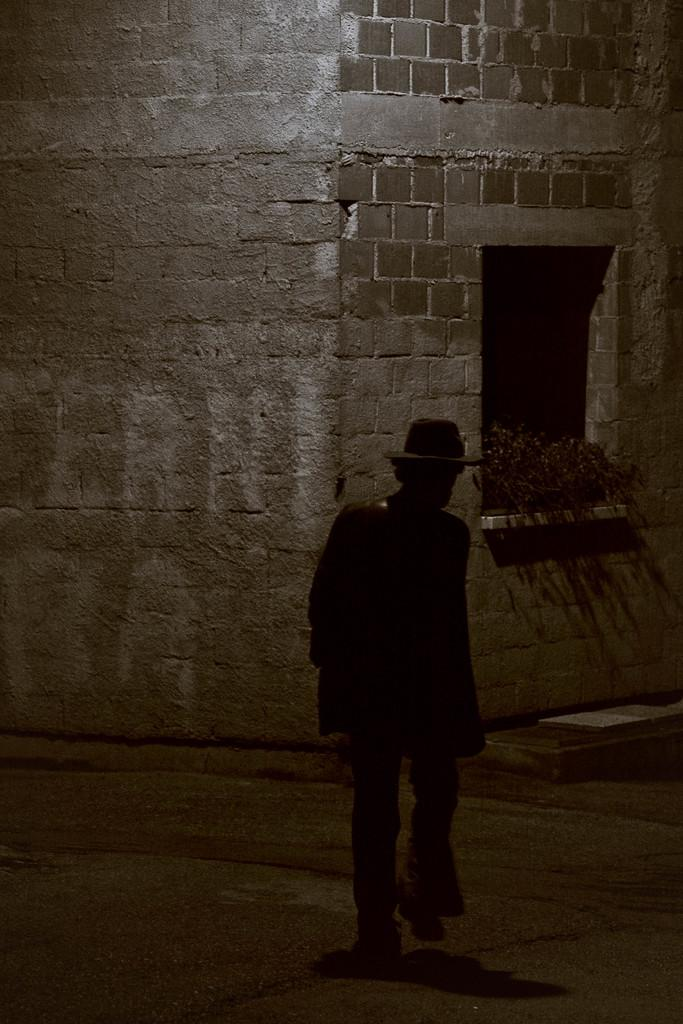What type of material is used to construct the building in the image? The building in the image is constructed with bricks. What can be seen near a window of the building? There are plants in front of a window of the building. What is happening in front of the building? A person is walking on a path in front of the building. What type of flock is flying over the building in the image? There is no flock visible in the image; it only shows a building, plants, and a person walking on a path. 